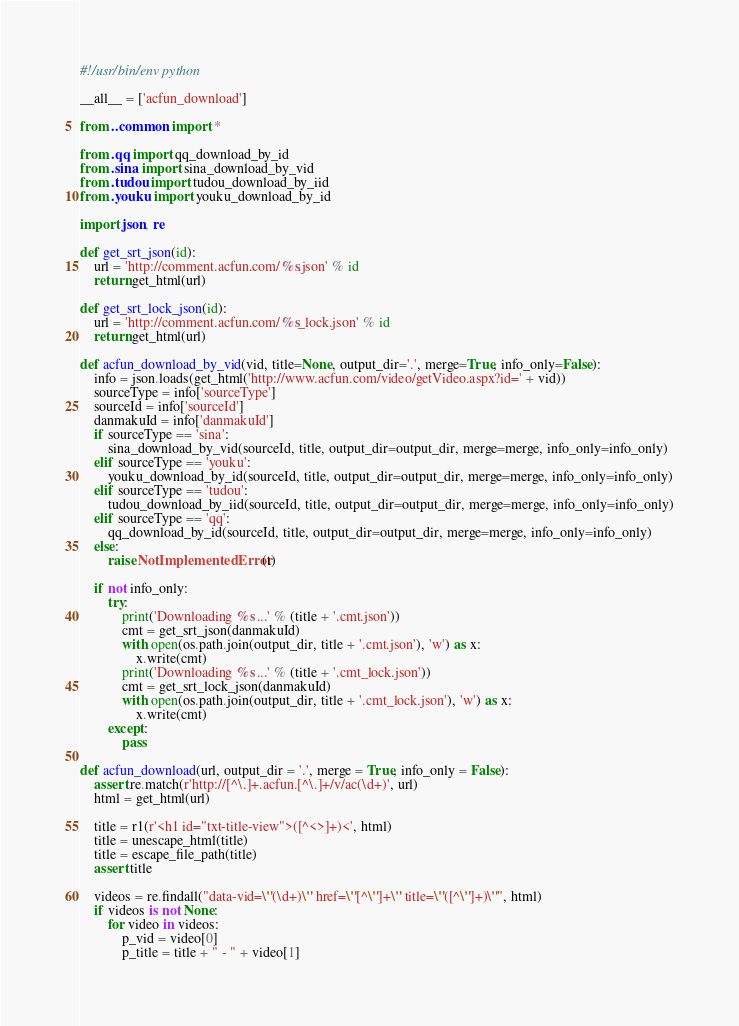Convert code to text. <code><loc_0><loc_0><loc_500><loc_500><_Python_>#!/usr/bin/env python

__all__ = ['acfun_download']

from ..common import *

from .qq import qq_download_by_id
from .sina import sina_download_by_vid
from .tudou import tudou_download_by_iid
from .youku import youku_download_by_id

import json, re

def get_srt_json(id):
    url = 'http://comment.acfun.com/%s.json' % id
    return get_html(url)

def get_srt_lock_json(id):
    url = 'http://comment.acfun.com/%s_lock.json' % id
    return get_html(url)

def acfun_download_by_vid(vid, title=None, output_dir='.', merge=True, info_only=False):
    info = json.loads(get_html('http://www.acfun.com/video/getVideo.aspx?id=' + vid))
    sourceType = info['sourceType']
    sourceId = info['sourceId']
    danmakuId = info['danmakuId']
    if sourceType == 'sina':
        sina_download_by_vid(sourceId, title, output_dir=output_dir, merge=merge, info_only=info_only)
    elif sourceType == 'youku':
        youku_download_by_id(sourceId, title, output_dir=output_dir, merge=merge, info_only=info_only)
    elif sourceType == 'tudou':
        tudou_download_by_iid(sourceId, title, output_dir=output_dir, merge=merge, info_only=info_only)
    elif sourceType == 'qq':
        qq_download_by_id(sourceId, title, output_dir=output_dir, merge=merge, info_only=info_only)
    else:
        raise NotImplementedError(t)

    if not info_only:
        try:
            print('Downloading %s ...' % (title + '.cmt.json'))
            cmt = get_srt_json(danmakuId)
            with open(os.path.join(output_dir, title + '.cmt.json'), 'w') as x:
                x.write(cmt)
            print('Downloading %s ...' % (title + '.cmt_lock.json'))
            cmt = get_srt_lock_json(danmakuId)
            with open(os.path.join(output_dir, title + '.cmt_lock.json'), 'w') as x:
                x.write(cmt)
        except:
            pass

def acfun_download(url, output_dir = '.', merge = True, info_only = False):
    assert re.match(r'http://[^\.]+.acfun.[^\.]+/v/ac(\d+)', url)
    html = get_html(url)

    title = r1(r'<h1 id="txt-title-view">([^<>]+)<', html)
    title = unescape_html(title)
    title = escape_file_path(title)
    assert title

    videos = re.findall("data-vid=\"(\d+)\" href=\"[^\"]+\" title=\"([^\"]+)\"", html)
    if videos is not None:
        for video in videos:
            p_vid = video[0]
            p_title = title + " - " + video[1]</code> 